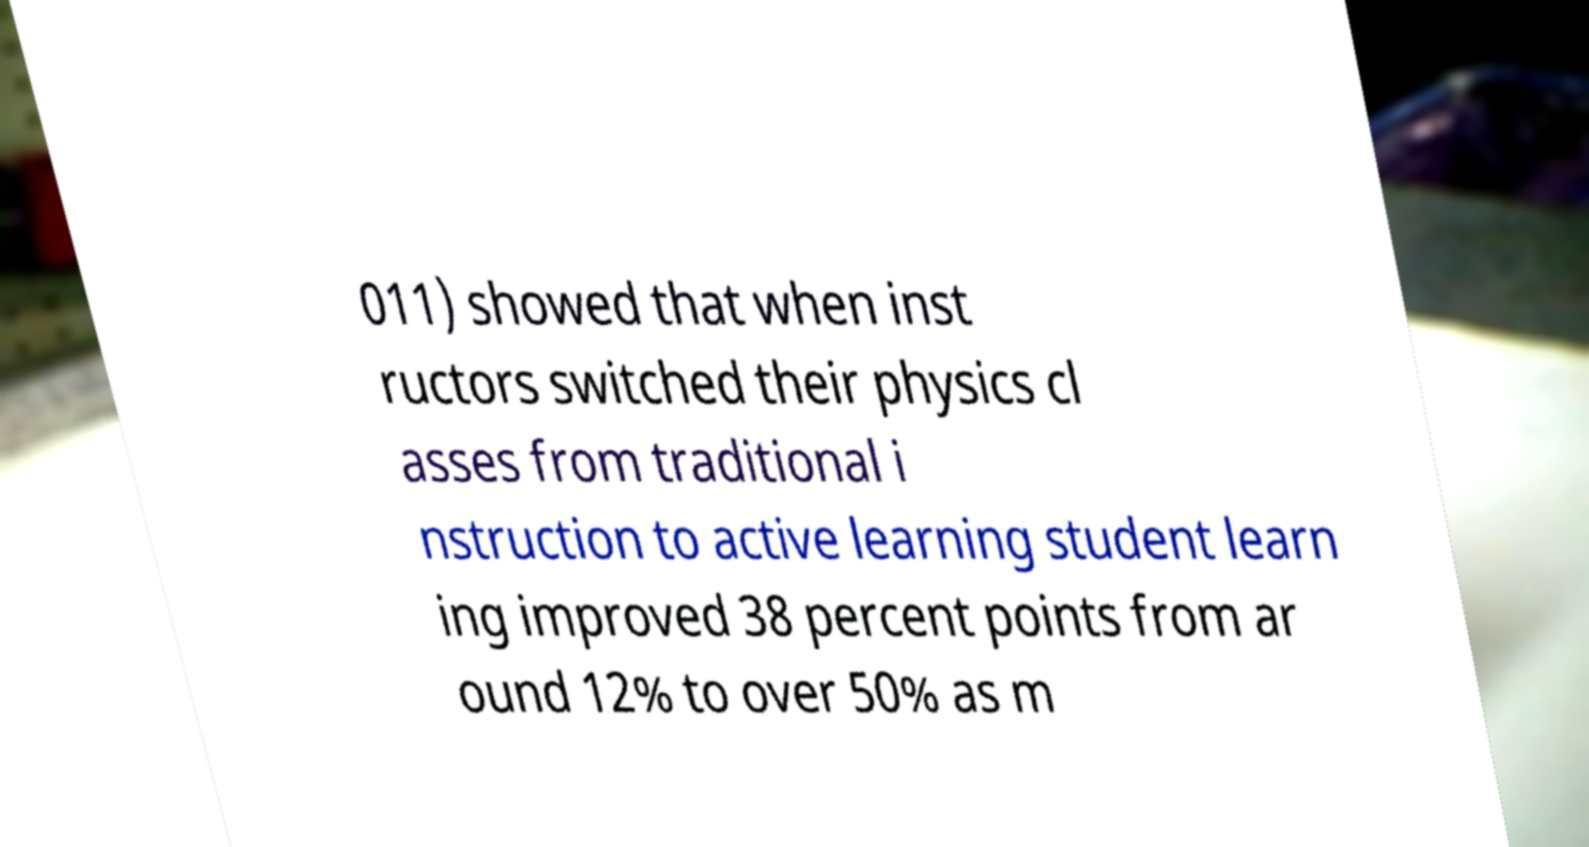Could you extract and type out the text from this image? 011) showed that when inst ructors switched their physics cl asses from traditional i nstruction to active learning student learn ing improved 38 percent points from ar ound 12% to over 50% as m 